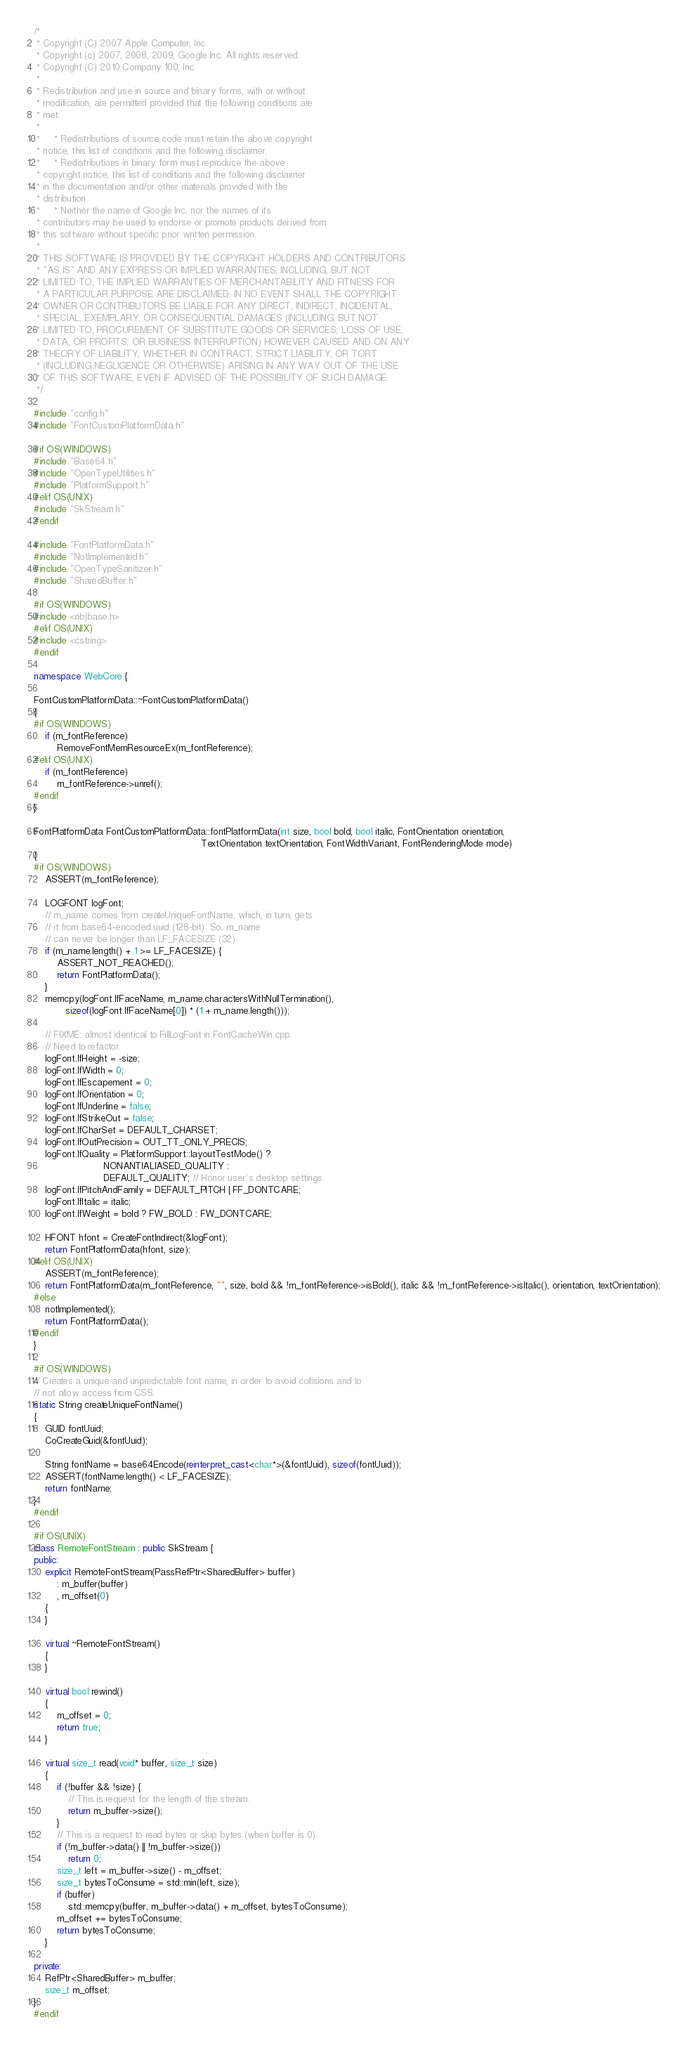<code> <loc_0><loc_0><loc_500><loc_500><_C++_>/*
 * Copyright (C) 2007 Apple Computer, Inc.
 * Copyright (c) 2007, 2008, 2009, Google Inc. All rights reserved.
 * Copyright (C) 2010 Company 100, Inc.
 * 
 * Redistribution and use in source and binary forms, with or without
 * modification, are permitted provided that the following conditions are
 * met:
 * 
 *     * Redistributions of source code must retain the above copyright
 * notice, this list of conditions and the following disclaimer.
 *     * Redistributions in binary form must reproduce the above
 * copyright notice, this list of conditions and the following disclaimer
 * in the documentation and/or other materials provided with the
 * distribution.
 *     * Neither the name of Google Inc. nor the names of its
 * contributors may be used to endorse or promote products derived from
 * this software without specific prior written permission.
 * 
 * THIS SOFTWARE IS PROVIDED BY THE COPYRIGHT HOLDERS AND CONTRIBUTORS
 * "AS IS" AND ANY EXPRESS OR IMPLIED WARRANTIES, INCLUDING, BUT NOT
 * LIMITED TO, THE IMPLIED WARRANTIES OF MERCHANTABILITY AND FITNESS FOR
 * A PARTICULAR PURPOSE ARE DISCLAIMED. IN NO EVENT SHALL THE COPYRIGHT
 * OWNER OR CONTRIBUTORS BE LIABLE FOR ANY DIRECT, INDIRECT, INCIDENTAL,
 * SPECIAL, EXEMPLARY, OR CONSEQUENTIAL DAMAGES (INCLUDING, BUT NOT
 * LIMITED TO, PROCUREMENT OF SUBSTITUTE GOODS OR SERVICES; LOSS OF USE,
 * DATA, OR PROFITS; OR BUSINESS INTERRUPTION) HOWEVER CAUSED AND ON ANY
 * THEORY OF LIABILITY, WHETHER IN CONTRACT, STRICT LIABILITY, OR TORT
 * (INCLUDING NEGLIGENCE OR OTHERWISE) ARISING IN ANY WAY OUT OF THE USE
 * OF THIS SOFTWARE, EVEN IF ADVISED OF THE POSSIBILITY OF SUCH DAMAGE.
 */

#include "config.h"
#include "FontCustomPlatformData.h"

#if OS(WINDOWS)
#include "Base64.h"
#include "OpenTypeUtilities.h"
#include "PlatformSupport.h"
#elif OS(UNIX)
#include "SkStream.h"
#endif

#include "FontPlatformData.h"
#include "NotImplemented.h"
#include "OpenTypeSanitizer.h"
#include "SharedBuffer.h"

#if OS(WINDOWS)
#include <objbase.h>
#elif OS(UNIX)
#include <cstring>
#endif

namespace WebCore {

FontCustomPlatformData::~FontCustomPlatformData()
{
#if OS(WINDOWS)
    if (m_fontReference)
        RemoveFontMemResourceEx(m_fontReference);
#elif OS(UNIX)
    if (m_fontReference)
        m_fontReference->unref();
#endif
}

FontPlatformData FontCustomPlatformData::fontPlatformData(int size, bool bold, bool italic, FontOrientation orientation,
                                                          TextOrientation textOrientation, FontWidthVariant, FontRenderingMode mode)
{
#if OS(WINDOWS)
    ASSERT(m_fontReference);

    LOGFONT logFont;
    // m_name comes from createUniqueFontName, which, in turn, gets
    // it from base64-encoded uuid (128-bit). So, m_name
    // can never be longer than LF_FACESIZE (32).
    if (m_name.length() + 1 >= LF_FACESIZE) {
        ASSERT_NOT_REACHED();
        return FontPlatformData();
    }
    memcpy(logFont.lfFaceName, m_name.charactersWithNullTermination(),
           sizeof(logFont.lfFaceName[0]) * (1 + m_name.length()));

    // FIXME: almost identical to FillLogFont in FontCacheWin.cpp.
    // Need to refactor. 
    logFont.lfHeight = -size;
    logFont.lfWidth = 0;
    logFont.lfEscapement = 0;
    logFont.lfOrientation = 0;
    logFont.lfUnderline = false;
    logFont.lfStrikeOut = false;
    logFont.lfCharSet = DEFAULT_CHARSET;
    logFont.lfOutPrecision = OUT_TT_ONLY_PRECIS;
    logFont.lfQuality = PlatformSupport::layoutTestMode() ?
                        NONANTIALIASED_QUALITY :
                        DEFAULT_QUALITY; // Honor user's desktop settings.
    logFont.lfPitchAndFamily = DEFAULT_PITCH | FF_DONTCARE;
    logFont.lfItalic = italic;
    logFont.lfWeight = bold ? FW_BOLD : FW_DONTCARE;

    HFONT hfont = CreateFontIndirect(&logFont);
    return FontPlatformData(hfont, size);
#elif OS(UNIX)
    ASSERT(m_fontReference);
    return FontPlatformData(m_fontReference, "", size, bold && !m_fontReference->isBold(), italic && !m_fontReference->isItalic(), orientation, textOrientation);
#else
    notImplemented();
    return FontPlatformData();
#endif
}

#if OS(WINDOWS)
// Creates a unique and unpredictable font name, in order to avoid collisions and to
// not allow access from CSS.
static String createUniqueFontName()
{
    GUID fontUuid;
    CoCreateGuid(&fontUuid);

    String fontName = base64Encode(reinterpret_cast<char*>(&fontUuid), sizeof(fontUuid));
    ASSERT(fontName.length() < LF_FACESIZE);
    return fontName;
}
#endif

#if OS(UNIX)
class RemoteFontStream : public SkStream {
public:
    explicit RemoteFontStream(PassRefPtr<SharedBuffer> buffer)
        : m_buffer(buffer)
        , m_offset(0)
    {
    }

    virtual ~RemoteFontStream()
    {
    }

    virtual bool rewind()
    {
        m_offset = 0;
        return true;
    }

    virtual size_t read(void* buffer, size_t size)
    {
        if (!buffer && !size) {
            // This is request for the length of the stream.
            return m_buffer->size();
        }
        // This is a request to read bytes or skip bytes (when buffer is 0).
        if (!m_buffer->data() || !m_buffer->size())
            return 0;
        size_t left = m_buffer->size() - m_offset;
        size_t bytesToConsume = std::min(left, size);
        if (buffer)
            std::memcpy(buffer, m_buffer->data() + m_offset, bytesToConsume);
        m_offset += bytesToConsume;
        return bytesToConsume;
    }

private:
    RefPtr<SharedBuffer> m_buffer;
    size_t m_offset;
};
#endif
</code> 